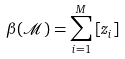Convert formula to latex. <formula><loc_0><loc_0><loc_500><loc_500>\beta ( \mathcal { M } ) = \sum _ { i = 1 } ^ { M } \left [ z _ { i } \right ]</formula> 